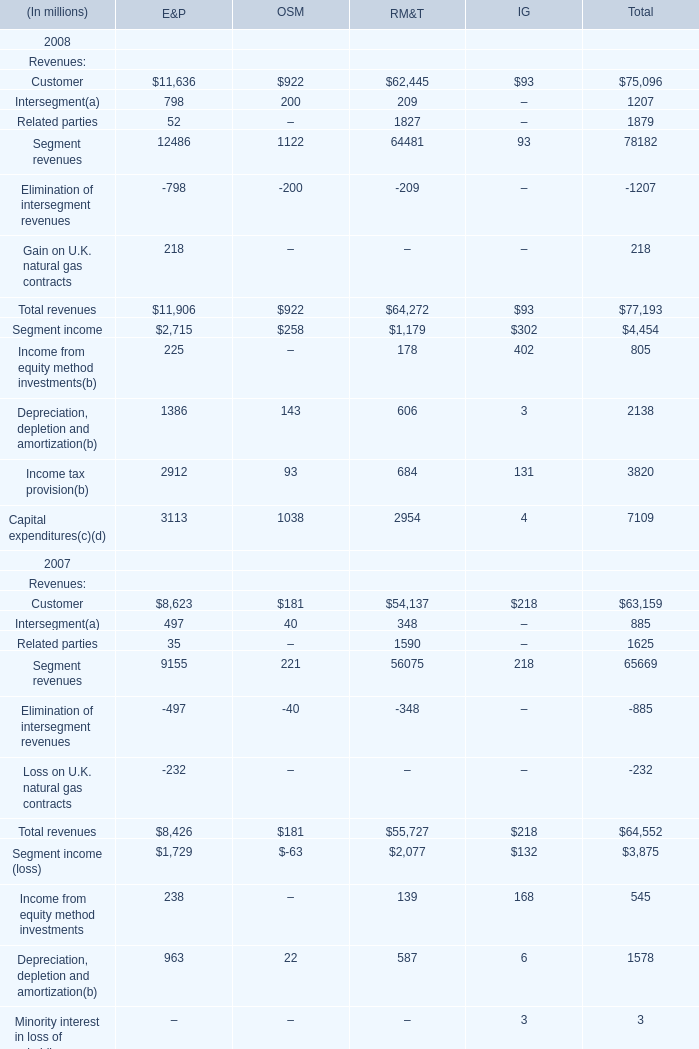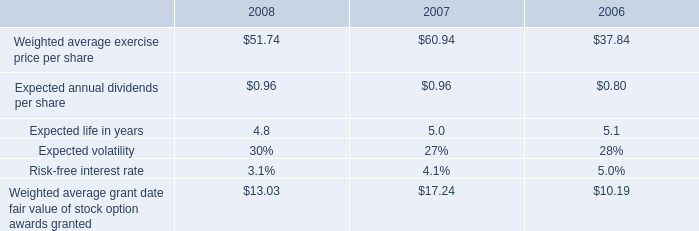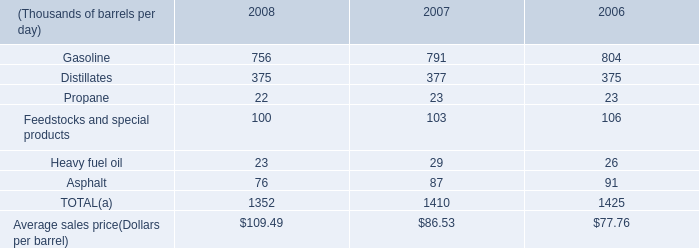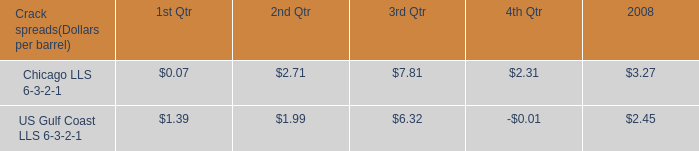what was the average crack spread for us gulf coast lls 6-3-2-1 in the first and second quarter of 2008? 
Computations: ((1.39 + 1.99) / 2)
Answer: 1.69. 